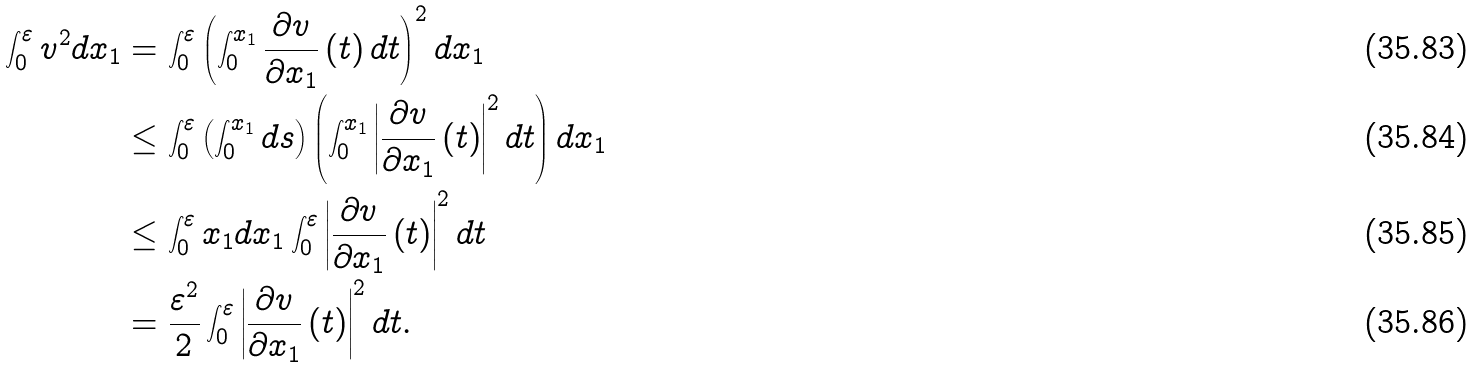Convert formula to latex. <formula><loc_0><loc_0><loc_500><loc_500>\int _ { 0 } ^ { \varepsilon } v ^ { 2 } d x _ { 1 } & = \int _ { 0 } ^ { \varepsilon } \left ( \int _ { 0 } ^ { x _ { 1 } } \frac { \partial v } { \partial x _ { 1 } } \left ( t \right ) d t \right ) ^ { 2 } d x _ { 1 } \\ & \leq \int _ { 0 } ^ { \varepsilon } \left ( \int _ { 0 } ^ { x _ { 1 } } d s \right ) \left ( \int _ { 0 } ^ { x _ { 1 } } \left | \frac { \partial v } { \partial x _ { 1 } } \left ( t \right ) \right | ^ { 2 } d t \right ) d x _ { 1 } \\ & \leq \int _ { 0 } ^ { \varepsilon } x _ { 1 } d x _ { 1 } \int _ { 0 } ^ { \varepsilon } \left | \frac { \partial v } { \partial x _ { 1 } } \left ( t \right ) \right | ^ { 2 } d t \\ & = \frac { \varepsilon ^ { 2 } } { 2 } \int _ { 0 } ^ { \varepsilon } \left | \frac { \partial v } { \partial x _ { 1 } } \left ( t \right ) \right | ^ { 2 } d t .</formula> 